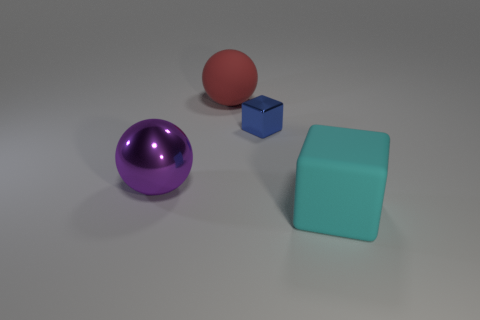The matte thing that is the same size as the cyan cube is what color? The object you are referring to, which shares the same size as the cyan cube, is colored red. This adds a vibrant contrast to the mostly subdued palette of the scene. 